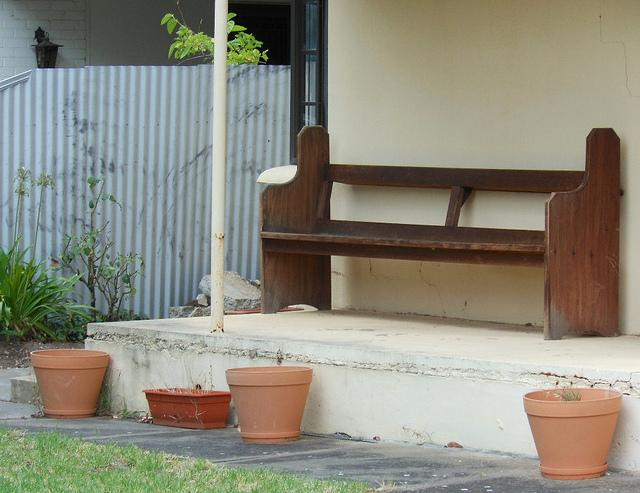What element is needed for the contents of the pots to extend their lives? water 